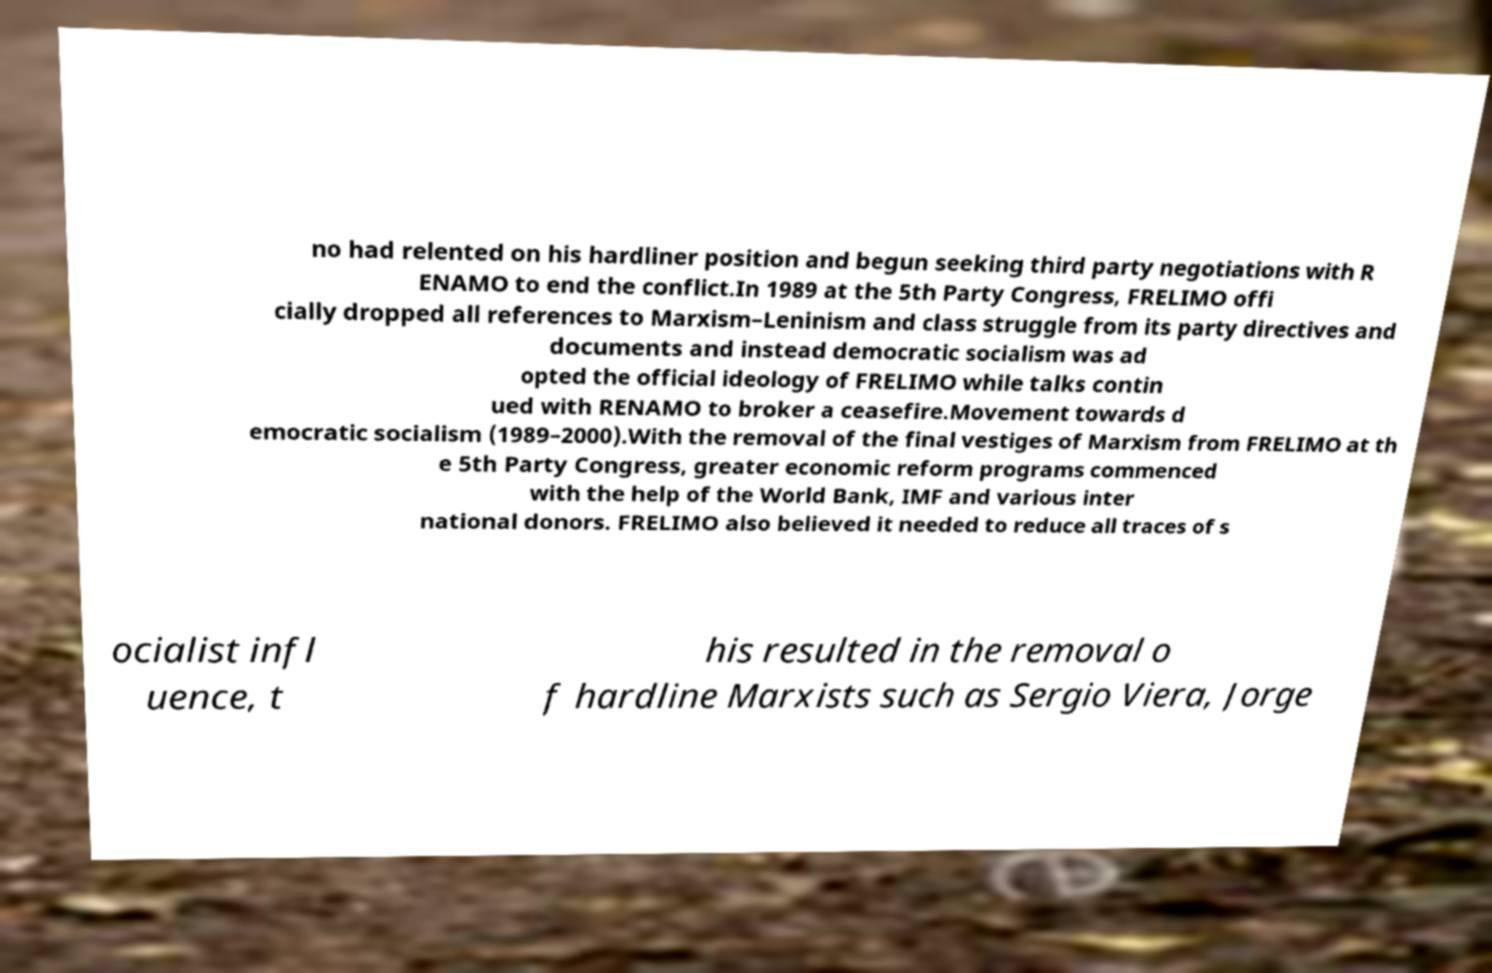There's text embedded in this image that I need extracted. Can you transcribe it verbatim? no had relented on his hardliner position and begun seeking third party negotiations with R ENAMO to end the conflict.In 1989 at the 5th Party Congress, FRELIMO offi cially dropped all references to Marxism–Leninism and class struggle from its party directives and documents and instead democratic socialism was ad opted the official ideology of FRELIMO while talks contin ued with RENAMO to broker a ceasefire.Movement towards d emocratic socialism (1989–2000).With the removal of the final vestiges of Marxism from FRELIMO at th e 5th Party Congress, greater economic reform programs commenced with the help of the World Bank, IMF and various inter national donors. FRELIMO also believed it needed to reduce all traces of s ocialist infl uence, t his resulted in the removal o f hardline Marxists such as Sergio Viera, Jorge 